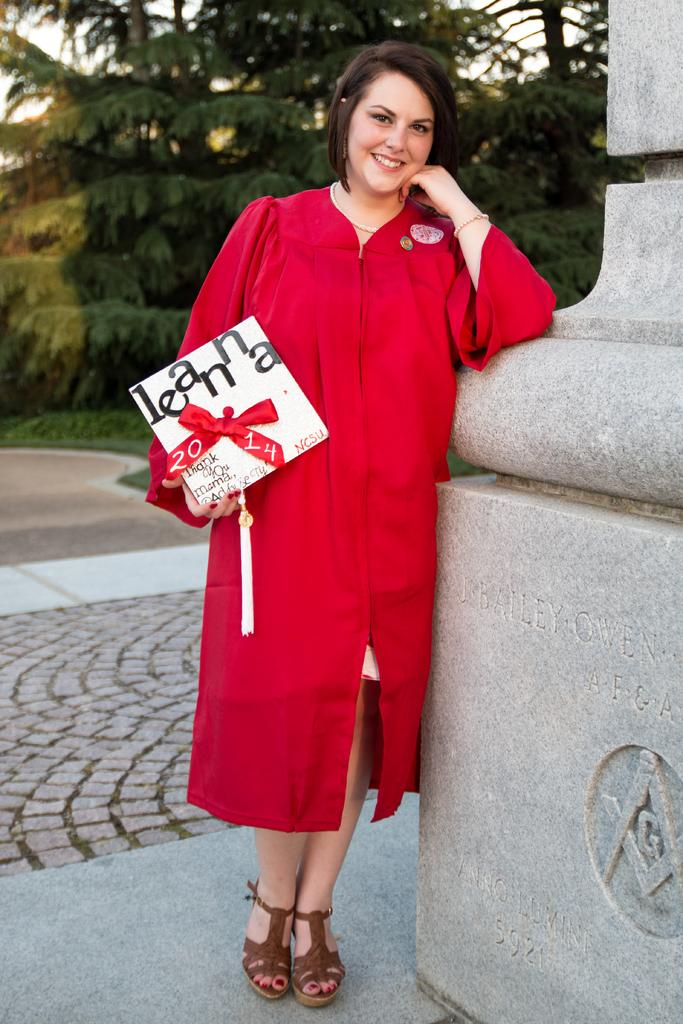What is the main subject of the image? The main subject of the image is a woman. What is the woman doing in the image? The woman is standing in the image. What is the woman holding in the image? The woman is holding a gift in the image. What can be seen on the gift? There is text on the gift. What is located beside the woman in the image? There is a wall structure beside the woman in the image. What type of vegetation is visible behind the woman? There are trees visible behind the woman in the image. What type of breakfast is the woman eating in the image? There is no breakfast visible in the image; the woman is holding a gift. Can you see a baby in the image? There is no baby present in the image; the main subject is a woman holding a gift. 